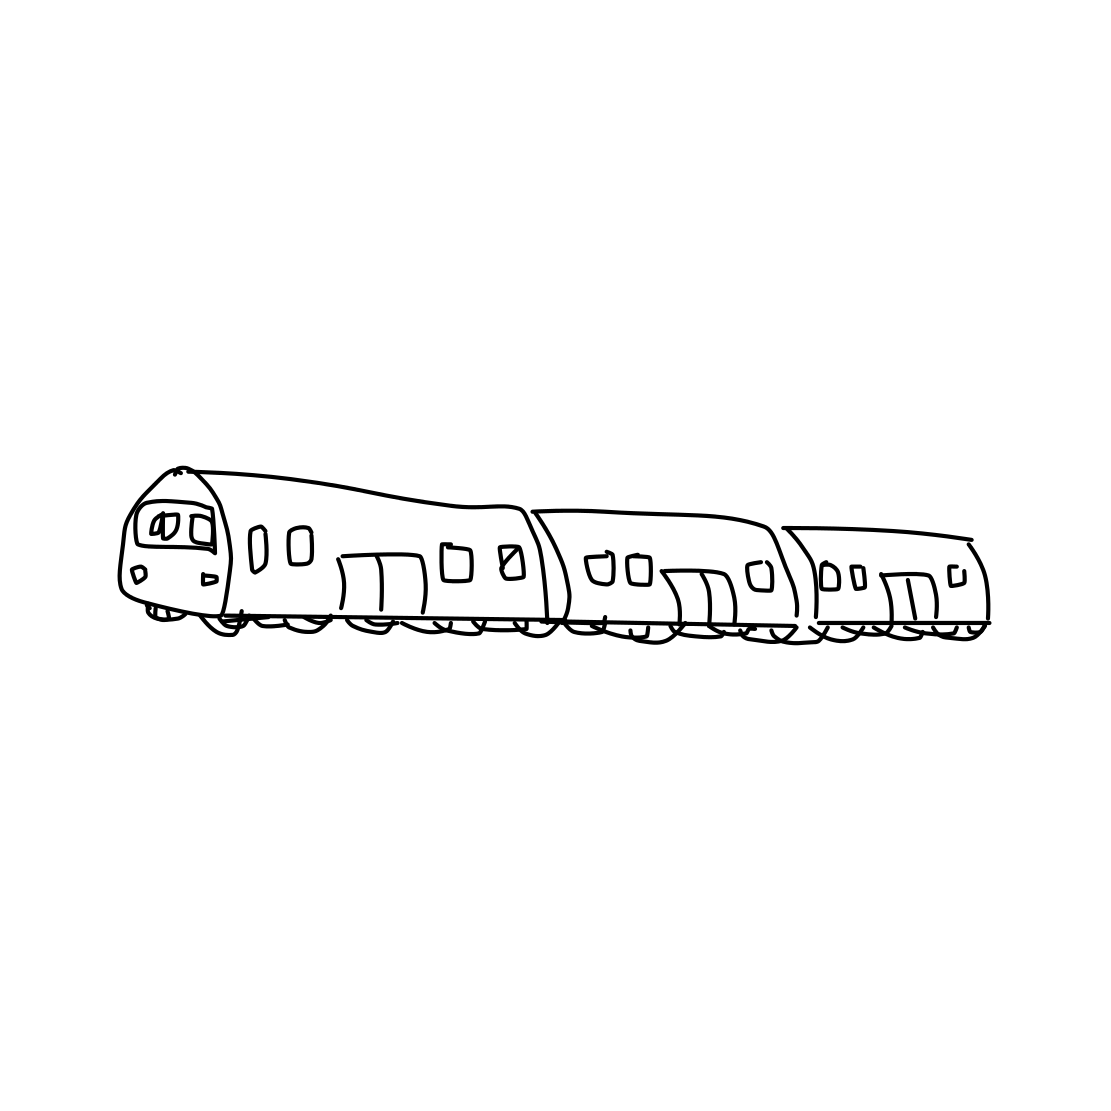Is there a sketchy sailboat in the picture? No 